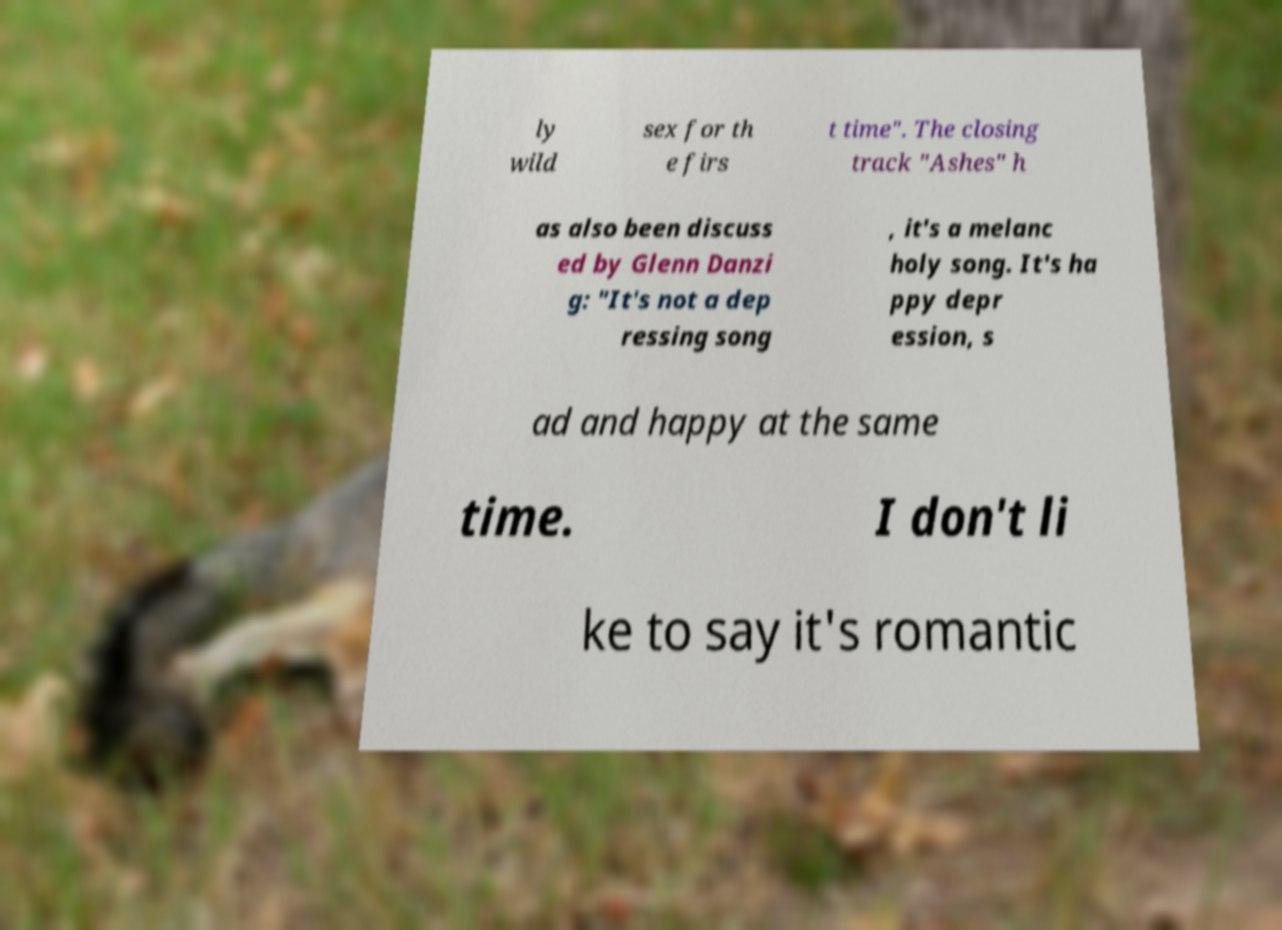Could you extract and type out the text from this image? ly wild sex for th e firs t time". The closing track "Ashes" h as also been discuss ed by Glenn Danzi g: "It's not a dep ressing song , it's a melanc holy song. It's ha ppy depr ession, s ad and happy at the same time. I don't li ke to say it's romantic 